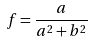Convert formula to latex. <formula><loc_0><loc_0><loc_500><loc_500>f = \frac { a } { a ^ { 2 } + b ^ { 2 } }</formula> 